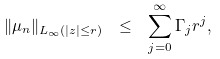<formula> <loc_0><loc_0><loc_500><loc_500>\| \mu _ { n } \| _ { L _ { \infty } ( | z | \leq r ) } \ \leq \ \sum _ { j = 0 } ^ { \infty } \Gamma _ { j } r ^ { j } ,</formula> 